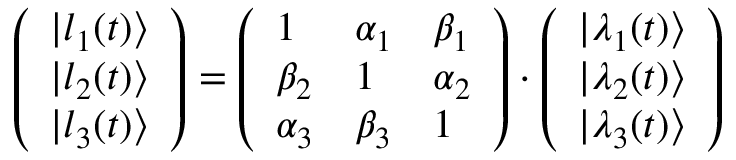<formula> <loc_0><loc_0><loc_500><loc_500>\left ( \begin{array} { l } { | l _ { 1 } ( t ) \rangle } \\ { | l _ { 2 } ( t ) \rangle } \\ { | l _ { 3 } ( t ) \rangle } \end{array} \right ) = \left ( \begin{array} { l l l } { 1 } & { \alpha _ { 1 } } & { \beta _ { 1 } } \\ { \beta _ { 2 } } & { 1 } & { \alpha _ { 2 } } \\ { \alpha _ { 3 } } & { \beta _ { 3 } } & { 1 } \end{array} \right ) \cdot \left ( \begin{array} { l } { | \lambda _ { 1 } ( t ) \rangle } \\ { | \lambda _ { 2 } ( t ) \rangle } \\ { | \lambda _ { 3 } ( t ) \rangle } \end{array} \right )</formula> 